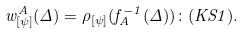Convert formula to latex. <formula><loc_0><loc_0><loc_500><loc_500>w ^ { A } _ { [ \psi ] } ( \Delta ) = \rho _ { [ \psi ] } ( f ^ { - 1 } _ { A } ( \Delta ) ) \colon ( K S 1 ) .</formula> 